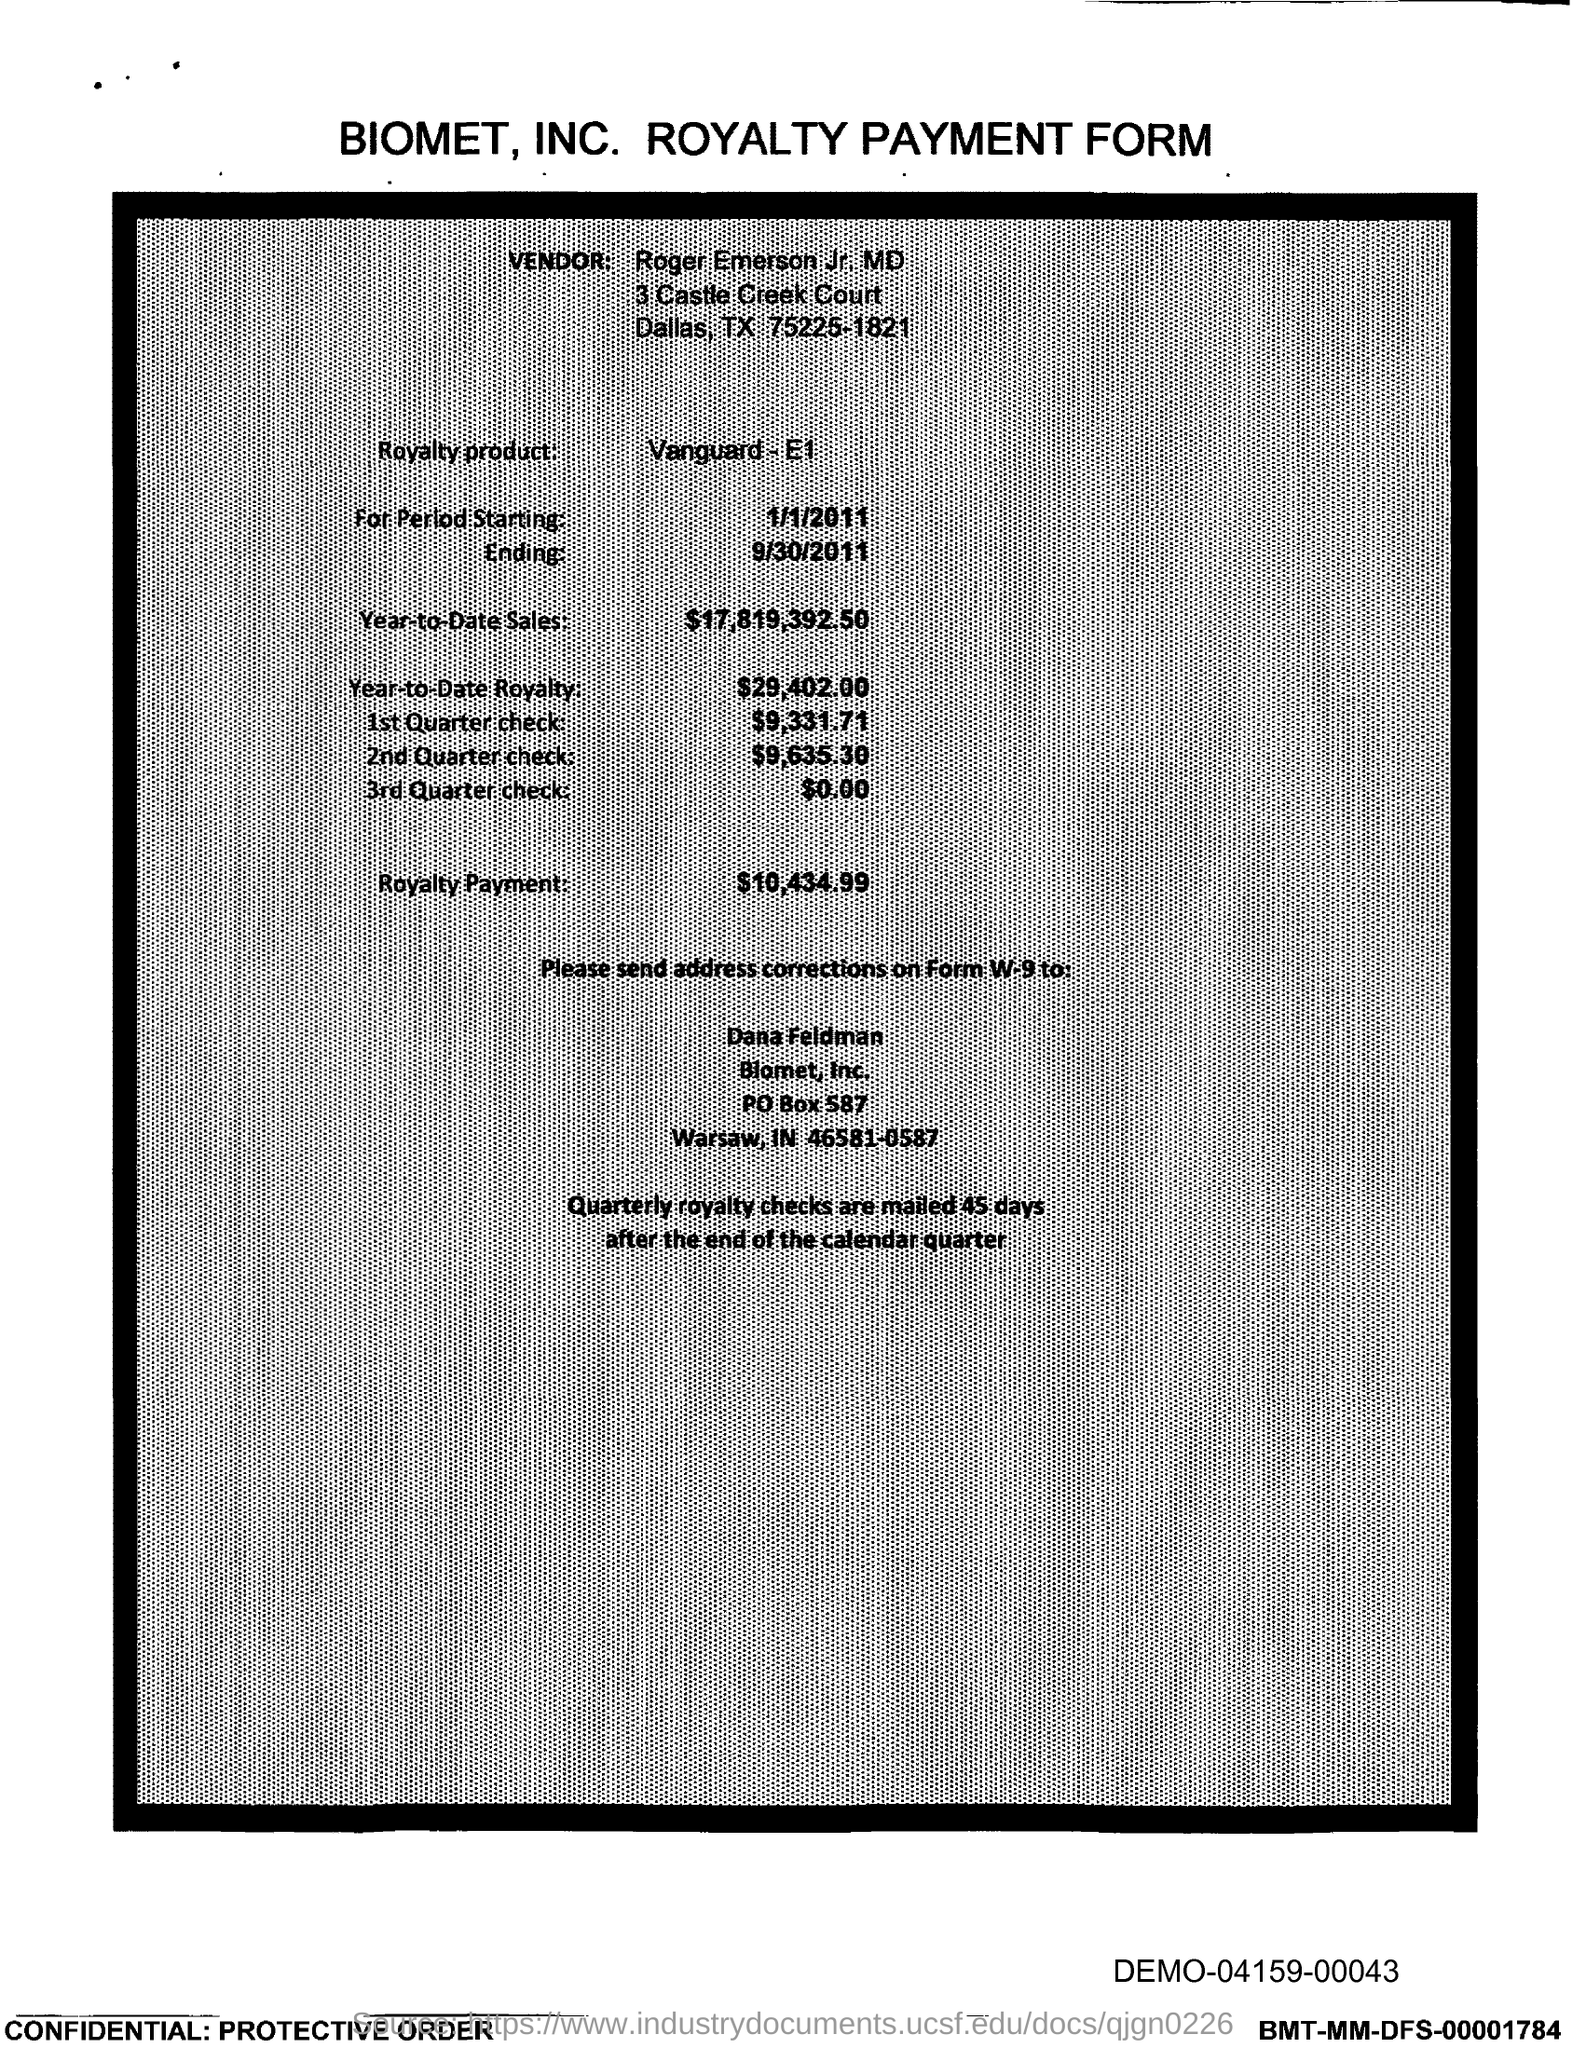Indicate a few pertinent items in this graphic. The amount mentioned in the form for the 2nd Quarter check is $9,635.30. The vendor mentioned in the form is Roger Emerson Jr. MD. The year-to-date royalty for the product is $29,402.00. The royalty payment form being referenced is that of Biomet, Inc. The royalty payment for the product mentioned in the form is $10,434.99. 